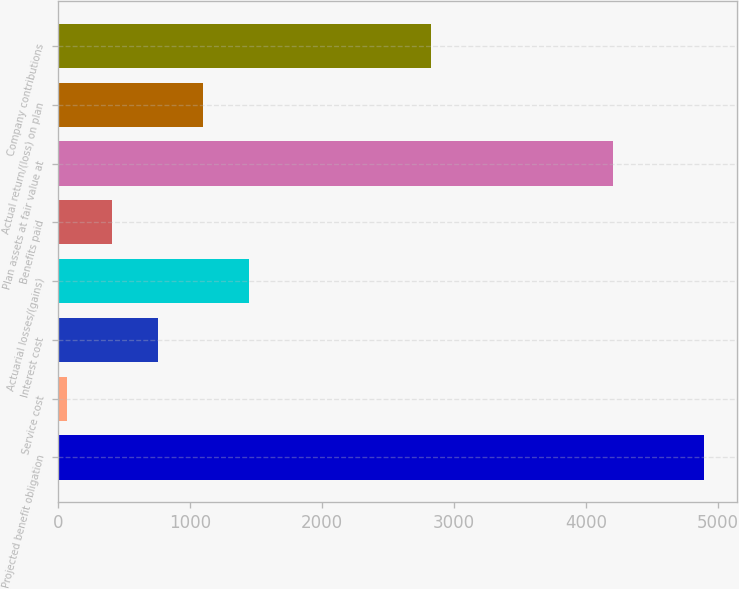Convert chart. <chart><loc_0><loc_0><loc_500><loc_500><bar_chart><fcel>Projected benefit obligation<fcel>Service cost<fcel>Interest cost<fcel>Actuarial losses/(gains)<fcel>Benefits paid<fcel>Plan assets at fair value at<fcel>Actual return/(loss) on plan<fcel>Company contributions<nl><fcel>4898.4<fcel>67<fcel>757.2<fcel>1447.4<fcel>412.1<fcel>4208.2<fcel>1102.3<fcel>2827.8<nl></chart> 